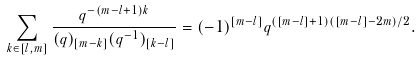Convert formula to latex. <formula><loc_0><loc_0><loc_500><loc_500>\sum _ { k \in [ l , m ] } \frac { q ^ { - ( m - l + 1 ) k } } { ( q ) _ { [ m - k ] } ( q ^ { - 1 } ) _ { [ k - l ] } } = ( - 1 ) ^ { [ m - l ] } q ^ { ( [ m - l ] + 1 ) ( [ m - l ] - 2 m ) / 2 } .</formula> 